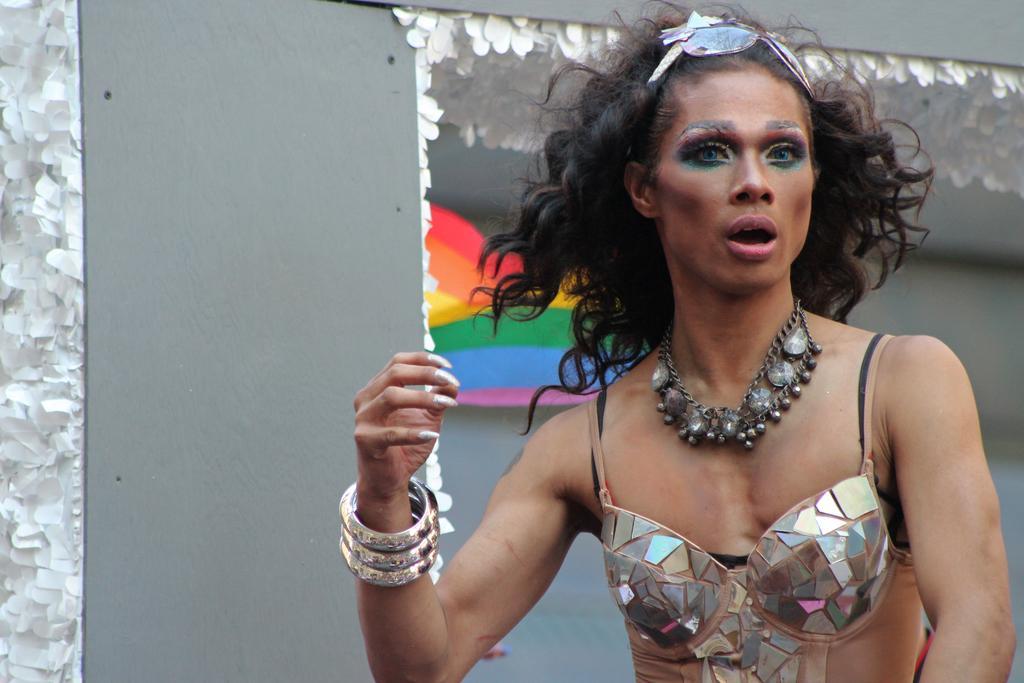Please provide a concise description of this image. In this image we can see a woman standing. On the backside we can see some decorative papers on a wall. 